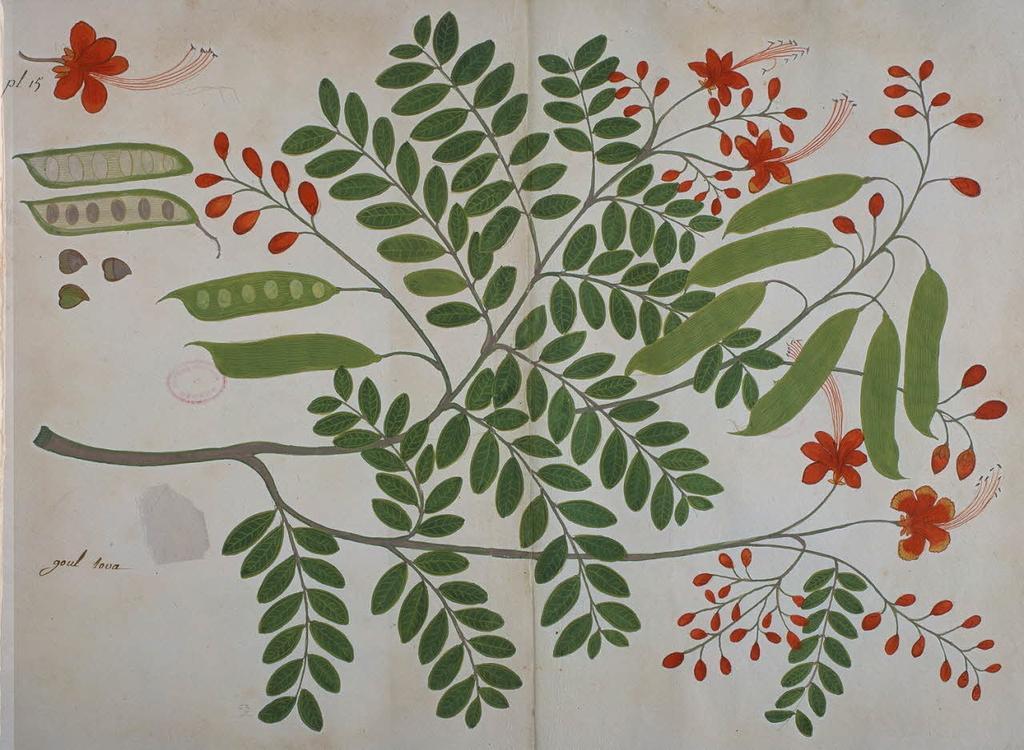How would you summarize this image in a sentence or two? In this image, we can see a curtain, on that curtain we can see some printed leaves and flowers. 